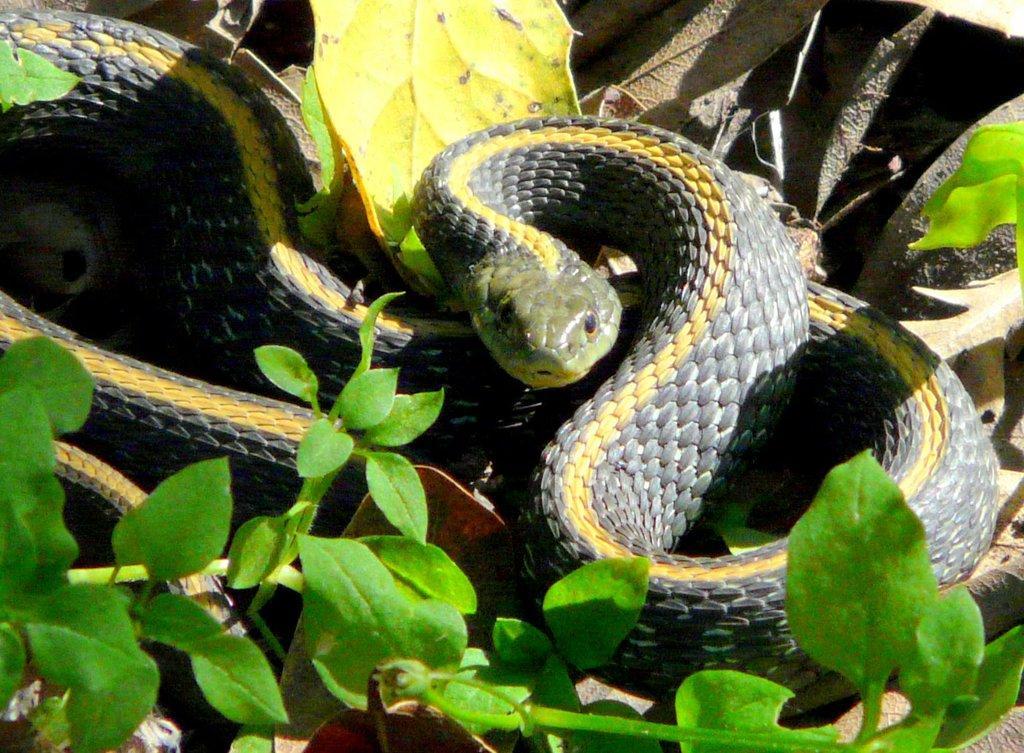In one or two sentences, can you explain what this image depicts? In this image I can see few snakes, they are in gray and yellow color, and I can see leaves in green color. 